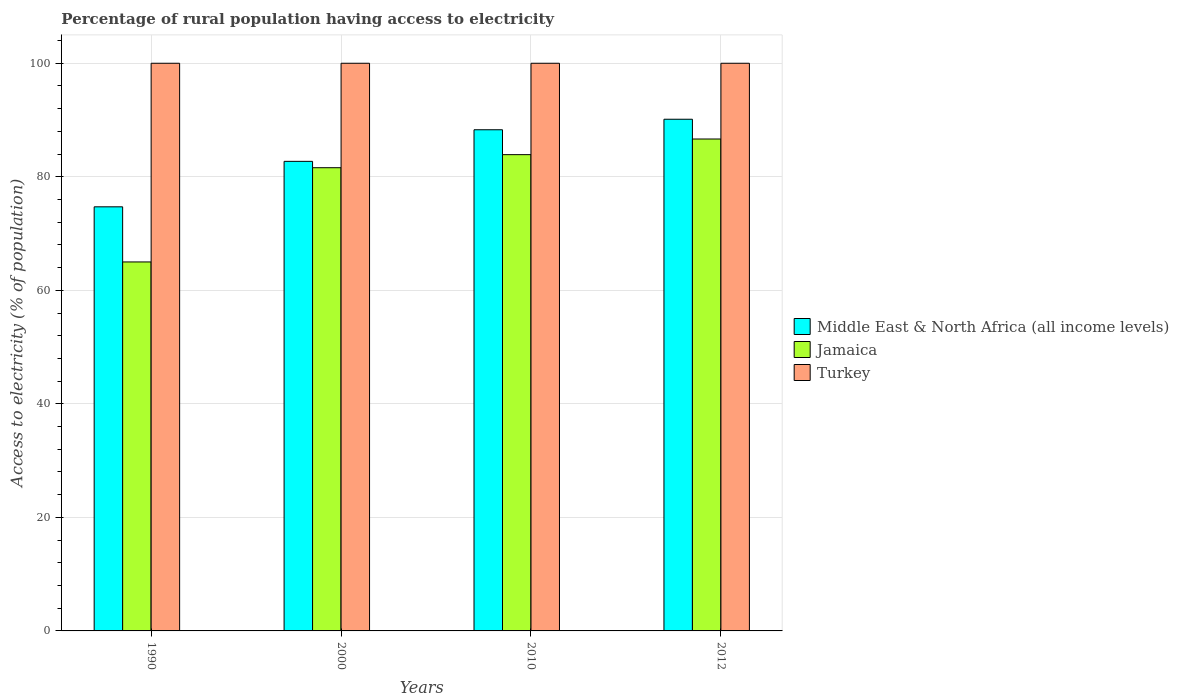How many bars are there on the 3rd tick from the left?
Provide a succinct answer. 3. How many bars are there on the 1st tick from the right?
Offer a very short reply. 3. What is the label of the 3rd group of bars from the left?
Give a very brief answer. 2010. In how many cases, is the number of bars for a given year not equal to the number of legend labels?
Provide a short and direct response. 0. What is the percentage of rural population having access to electricity in Jamaica in 2010?
Make the answer very short. 83.9. Across all years, what is the maximum percentage of rural population having access to electricity in Jamaica?
Provide a short and direct response. 86.65. Across all years, what is the minimum percentage of rural population having access to electricity in Jamaica?
Your answer should be very brief. 65. In which year was the percentage of rural population having access to electricity in Turkey minimum?
Your response must be concise. 1990. What is the total percentage of rural population having access to electricity in Turkey in the graph?
Offer a terse response. 400. What is the difference between the percentage of rural population having access to electricity in Middle East & North Africa (all income levels) in 2010 and that in 2012?
Make the answer very short. -1.85. What is the difference between the percentage of rural population having access to electricity in Middle East & North Africa (all income levels) in 2000 and the percentage of rural population having access to electricity in Turkey in 2010?
Your response must be concise. -17.28. What is the average percentage of rural population having access to electricity in Middle East & North Africa (all income levels) per year?
Offer a very short reply. 83.96. In the year 2010, what is the difference between the percentage of rural population having access to electricity in Middle East & North Africa (all income levels) and percentage of rural population having access to electricity in Jamaica?
Your answer should be very brief. 4.38. What is the ratio of the percentage of rural population having access to electricity in Turkey in 1990 to that in 2012?
Make the answer very short. 1. Is the difference between the percentage of rural population having access to electricity in Middle East & North Africa (all income levels) in 2000 and 2010 greater than the difference between the percentage of rural population having access to electricity in Jamaica in 2000 and 2010?
Make the answer very short. No. What is the difference between the highest and the second highest percentage of rural population having access to electricity in Middle East & North Africa (all income levels)?
Ensure brevity in your answer.  1.85. What is the difference between the highest and the lowest percentage of rural population having access to electricity in Jamaica?
Provide a succinct answer. 21.65. In how many years, is the percentage of rural population having access to electricity in Jamaica greater than the average percentage of rural population having access to electricity in Jamaica taken over all years?
Keep it short and to the point. 3. Is the sum of the percentage of rural population having access to electricity in Turkey in 2010 and 2012 greater than the maximum percentage of rural population having access to electricity in Jamaica across all years?
Offer a terse response. Yes. What does the 3rd bar from the left in 2010 represents?
Your answer should be compact. Turkey. What does the 3rd bar from the right in 2000 represents?
Give a very brief answer. Middle East & North Africa (all income levels). Is it the case that in every year, the sum of the percentage of rural population having access to electricity in Jamaica and percentage of rural population having access to electricity in Turkey is greater than the percentage of rural population having access to electricity in Middle East & North Africa (all income levels)?
Keep it short and to the point. Yes. How many years are there in the graph?
Ensure brevity in your answer.  4. What is the difference between two consecutive major ticks on the Y-axis?
Keep it short and to the point. 20. Where does the legend appear in the graph?
Your answer should be compact. Center right. How many legend labels are there?
Provide a succinct answer. 3. What is the title of the graph?
Provide a short and direct response. Percentage of rural population having access to electricity. What is the label or title of the X-axis?
Offer a terse response. Years. What is the label or title of the Y-axis?
Make the answer very short. Access to electricity (% of population). What is the Access to electricity (% of population) of Middle East & North Africa (all income levels) in 1990?
Make the answer very short. 74.71. What is the Access to electricity (% of population) in Jamaica in 1990?
Your answer should be compact. 65. What is the Access to electricity (% of population) of Middle East & North Africa (all income levels) in 2000?
Offer a very short reply. 82.72. What is the Access to electricity (% of population) in Jamaica in 2000?
Offer a very short reply. 81.6. What is the Access to electricity (% of population) in Turkey in 2000?
Make the answer very short. 100. What is the Access to electricity (% of population) of Middle East & North Africa (all income levels) in 2010?
Your answer should be very brief. 88.28. What is the Access to electricity (% of population) of Jamaica in 2010?
Keep it short and to the point. 83.9. What is the Access to electricity (% of population) in Turkey in 2010?
Your answer should be very brief. 100. What is the Access to electricity (% of population) in Middle East & North Africa (all income levels) in 2012?
Offer a very short reply. 90.14. What is the Access to electricity (% of population) of Jamaica in 2012?
Your answer should be very brief. 86.65. What is the Access to electricity (% of population) in Turkey in 2012?
Your response must be concise. 100. Across all years, what is the maximum Access to electricity (% of population) of Middle East & North Africa (all income levels)?
Provide a succinct answer. 90.14. Across all years, what is the maximum Access to electricity (% of population) in Jamaica?
Offer a terse response. 86.65. Across all years, what is the minimum Access to electricity (% of population) in Middle East & North Africa (all income levels)?
Keep it short and to the point. 74.71. Across all years, what is the minimum Access to electricity (% of population) in Jamaica?
Your response must be concise. 65. What is the total Access to electricity (% of population) in Middle East & North Africa (all income levels) in the graph?
Your answer should be very brief. 335.85. What is the total Access to electricity (% of population) in Jamaica in the graph?
Your answer should be compact. 317.15. What is the difference between the Access to electricity (% of population) in Middle East & North Africa (all income levels) in 1990 and that in 2000?
Provide a succinct answer. -8.01. What is the difference between the Access to electricity (% of population) of Jamaica in 1990 and that in 2000?
Offer a terse response. -16.6. What is the difference between the Access to electricity (% of population) in Middle East & North Africa (all income levels) in 1990 and that in 2010?
Provide a succinct answer. -13.57. What is the difference between the Access to electricity (% of population) of Jamaica in 1990 and that in 2010?
Give a very brief answer. -18.9. What is the difference between the Access to electricity (% of population) of Middle East & North Africa (all income levels) in 1990 and that in 2012?
Give a very brief answer. -15.43. What is the difference between the Access to electricity (% of population) of Jamaica in 1990 and that in 2012?
Provide a succinct answer. -21.65. What is the difference between the Access to electricity (% of population) in Turkey in 1990 and that in 2012?
Offer a very short reply. 0. What is the difference between the Access to electricity (% of population) of Middle East & North Africa (all income levels) in 2000 and that in 2010?
Keep it short and to the point. -5.56. What is the difference between the Access to electricity (% of population) in Turkey in 2000 and that in 2010?
Your answer should be compact. 0. What is the difference between the Access to electricity (% of population) of Middle East & North Africa (all income levels) in 2000 and that in 2012?
Provide a short and direct response. -7.42. What is the difference between the Access to electricity (% of population) in Jamaica in 2000 and that in 2012?
Make the answer very short. -5.05. What is the difference between the Access to electricity (% of population) of Middle East & North Africa (all income levels) in 2010 and that in 2012?
Give a very brief answer. -1.85. What is the difference between the Access to electricity (% of population) in Jamaica in 2010 and that in 2012?
Your response must be concise. -2.75. What is the difference between the Access to electricity (% of population) in Turkey in 2010 and that in 2012?
Provide a short and direct response. 0. What is the difference between the Access to electricity (% of population) in Middle East & North Africa (all income levels) in 1990 and the Access to electricity (% of population) in Jamaica in 2000?
Ensure brevity in your answer.  -6.89. What is the difference between the Access to electricity (% of population) in Middle East & North Africa (all income levels) in 1990 and the Access to electricity (% of population) in Turkey in 2000?
Provide a succinct answer. -25.29. What is the difference between the Access to electricity (% of population) in Jamaica in 1990 and the Access to electricity (% of population) in Turkey in 2000?
Offer a terse response. -35. What is the difference between the Access to electricity (% of population) in Middle East & North Africa (all income levels) in 1990 and the Access to electricity (% of population) in Jamaica in 2010?
Your answer should be very brief. -9.19. What is the difference between the Access to electricity (% of population) of Middle East & North Africa (all income levels) in 1990 and the Access to electricity (% of population) of Turkey in 2010?
Give a very brief answer. -25.29. What is the difference between the Access to electricity (% of population) of Jamaica in 1990 and the Access to electricity (% of population) of Turkey in 2010?
Your answer should be compact. -35. What is the difference between the Access to electricity (% of population) of Middle East & North Africa (all income levels) in 1990 and the Access to electricity (% of population) of Jamaica in 2012?
Offer a terse response. -11.94. What is the difference between the Access to electricity (% of population) of Middle East & North Africa (all income levels) in 1990 and the Access to electricity (% of population) of Turkey in 2012?
Provide a short and direct response. -25.29. What is the difference between the Access to electricity (% of population) of Jamaica in 1990 and the Access to electricity (% of population) of Turkey in 2012?
Give a very brief answer. -35. What is the difference between the Access to electricity (% of population) of Middle East & North Africa (all income levels) in 2000 and the Access to electricity (% of population) of Jamaica in 2010?
Offer a very short reply. -1.18. What is the difference between the Access to electricity (% of population) in Middle East & North Africa (all income levels) in 2000 and the Access to electricity (% of population) in Turkey in 2010?
Your response must be concise. -17.28. What is the difference between the Access to electricity (% of population) in Jamaica in 2000 and the Access to electricity (% of population) in Turkey in 2010?
Your answer should be compact. -18.4. What is the difference between the Access to electricity (% of population) in Middle East & North Africa (all income levels) in 2000 and the Access to electricity (% of population) in Jamaica in 2012?
Provide a succinct answer. -3.93. What is the difference between the Access to electricity (% of population) of Middle East & North Africa (all income levels) in 2000 and the Access to electricity (% of population) of Turkey in 2012?
Your answer should be compact. -17.28. What is the difference between the Access to electricity (% of population) in Jamaica in 2000 and the Access to electricity (% of population) in Turkey in 2012?
Offer a very short reply. -18.4. What is the difference between the Access to electricity (% of population) in Middle East & North Africa (all income levels) in 2010 and the Access to electricity (% of population) in Jamaica in 2012?
Ensure brevity in your answer.  1.63. What is the difference between the Access to electricity (% of population) of Middle East & North Africa (all income levels) in 2010 and the Access to electricity (% of population) of Turkey in 2012?
Your answer should be very brief. -11.72. What is the difference between the Access to electricity (% of population) of Jamaica in 2010 and the Access to electricity (% of population) of Turkey in 2012?
Keep it short and to the point. -16.1. What is the average Access to electricity (% of population) in Middle East & North Africa (all income levels) per year?
Your response must be concise. 83.96. What is the average Access to electricity (% of population) of Jamaica per year?
Your response must be concise. 79.29. In the year 1990, what is the difference between the Access to electricity (% of population) of Middle East & North Africa (all income levels) and Access to electricity (% of population) of Jamaica?
Offer a terse response. 9.71. In the year 1990, what is the difference between the Access to electricity (% of population) in Middle East & North Africa (all income levels) and Access to electricity (% of population) in Turkey?
Give a very brief answer. -25.29. In the year 1990, what is the difference between the Access to electricity (% of population) of Jamaica and Access to electricity (% of population) of Turkey?
Provide a short and direct response. -35. In the year 2000, what is the difference between the Access to electricity (% of population) in Middle East & North Africa (all income levels) and Access to electricity (% of population) in Jamaica?
Make the answer very short. 1.12. In the year 2000, what is the difference between the Access to electricity (% of population) of Middle East & North Africa (all income levels) and Access to electricity (% of population) of Turkey?
Offer a very short reply. -17.28. In the year 2000, what is the difference between the Access to electricity (% of population) of Jamaica and Access to electricity (% of population) of Turkey?
Offer a terse response. -18.4. In the year 2010, what is the difference between the Access to electricity (% of population) in Middle East & North Africa (all income levels) and Access to electricity (% of population) in Jamaica?
Your answer should be very brief. 4.38. In the year 2010, what is the difference between the Access to electricity (% of population) of Middle East & North Africa (all income levels) and Access to electricity (% of population) of Turkey?
Give a very brief answer. -11.72. In the year 2010, what is the difference between the Access to electricity (% of population) of Jamaica and Access to electricity (% of population) of Turkey?
Provide a short and direct response. -16.1. In the year 2012, what is the difference between the Access to electricity (% of population) in Middle East & North Africa (all income levels) and Access to electricity (% of population) in Jamaica?
Provide a succinct answer. 3.48. In the year 2012, what is the difference between the Access to electricity (% of population) in Middle East & North Africa (all income levels) and Access to electricity (% of population) in Turkey?
Make the answer very short. -9.86. In the year 2012, what is the difference between the Access to electricity (% of population) in Jamaica and Access to electricity (% of population) in Turkey?
Ensure brevity in your answer.  -13.35. What is the ratio of the Access to electricity (% of population) of Middle East & North Africa (all income levels) in 1990 to that in 2000?
Provide a succinct answer. 0.9. What is the ratio of the Access to electricity (% of population) in Jamaica in 1990 to that in 2000?
Your response must be concise. 0.8. What is the ratio of the Access to electricity (% of population) of Turkey in 1990 to that in 2000?
Your answer should be compact. 1. What is the ratio of the Access to electricity (% of population) in Middle East & North Africa (all income levels) in 1990 to that in 2010?
Your response must be concise. 0.85. What is the ratio of the Access to electricity (% of population) in Jamaica in 1990 to that in 2010?
Your answer should be compact. 0.77. What is the ratio of the Access to electricity (% of population) in Turkey in 1990 to that in 2010?
Provide a succinct answer. 1. What is the ratio of the Access to electricity (% of population) in Middle East & North Africa (all income levels) in 1990 to that in 2012?
Offer a very short reply. 0.83. What is the ratio of the Access to electricity (% of population) of Jamaica in 1990 to that in 2012?
Your response must be concise. 0.75. What is the ratio of the Access to electricity (% of population) in Middle East & North Africa (all income levels) in 2000 to that in 2010?
Offer a very short reply. 0.94. What is the ratio of the Access to electricity (% of population) of Jamaica in 2000 to that in 2010?
Provide a short and direct response. 0.97. What is the ratio of the Access to electricity (% of population) in Turkey in 2000 to that in 2010?
Give a very brief answer. 1. What is the ratio of the Access to electricity (% of population) in Middle East & North Africa (all income levels) in 2000 to that in 2012?
Make the answer very short. 0.92. What is the ratio of the Access to electricity (% of population) of Jamaica in 2000 to that in 2012?
Provide a short and direct response. 0.94. What is the ratio of the Access to electricity (% of population) in Turkey in 2000 to that in 2012?
Provide a short and direct response. 1. What is the ratio of the Access to electricity (% of population) of Middle East & North Africa (all income levels) in 2010 to that in 2012?
Keep it short and to the point. 0.98. What is the ratio of the Access to electricity (% of population) of Jamaica in 2010 to that in 2012?
Make the answer very short. 0.97. What is the ratio of the Access to electricity (% of population) of Turkey in 2010 to that in 2012?
Your response must be concise. 1. What is the difference between the highest and the second highest Access to electricity (% of population) of Middle East & North Africa (all income levels)?
Your answer should be very brief. 1.85. What is the difference between the highest and the second highest Access to electricity (% of population) in Jamaica?
Offer a terse response. 2.75. What is the difference between the highest and the lowest Access to electricity (% of population) in Middle East & North Africa (all income levels)?
Provide a short and direct response. 15.43. What is the difference between the highest and the lowest Access to electricity (% of population) in Jamaica?
Provide a succinct answer. 21.65. 